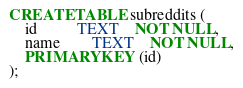<code> <loc_0><loc_0><loc_500><loc_500><_SQL_>CREATE TABLE subreddits (
    id          TEXT    NOT NULL, 
    name        TEXT    NOT NULL,
    PRIMARY KEY (id)
);</code> 